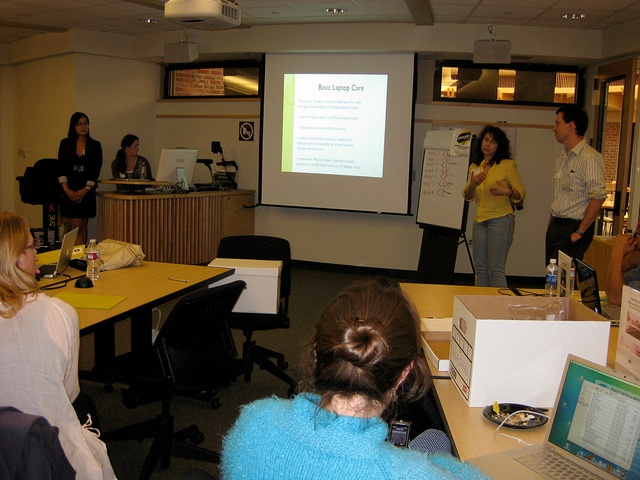Describe the objects in this image and their specific colors. I can see people in maroon, black, darkgray, and lightblue tones, laptop in maroon, tan, darkgray, teal, and gray tones, dining table in maroon, olive, and black tones, people in maroon, black, and olive tones, and people in maroon, black, and gray tones in this image. 